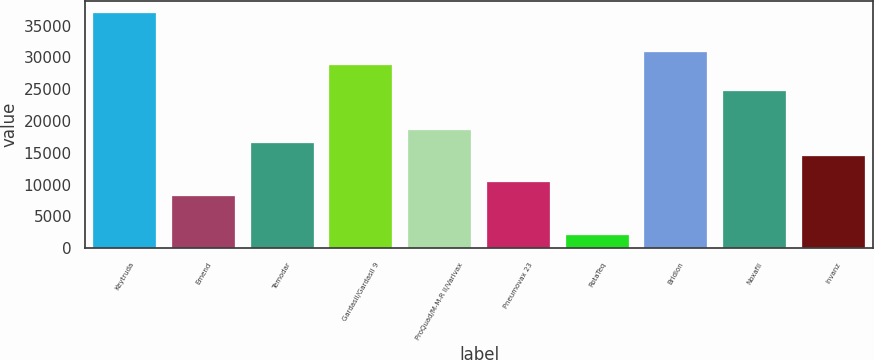<chart> <loc_0><loc_0><loc_500><loc_500><bar_chart><fcel>Keytruda<fcel>Emend<fcel>Temodar<fcel>Gardasil/Gardasil 9<fcel>ProQuad/M-M-R II/Varivax<fcel>Pneumovax 23<fcel>RotaTeq<fcel>Bridion<fcel>Noxafil<fcel>Invanz<nl><fcel>36962.8<fcel>8268.4<fcel>16466.8<fcel>28764.4<fcel>18516.4<fcel>10318<fcel>2119.6<fcel>30814<fcel>24665.2<fcel>14417.2<nl></chart> 